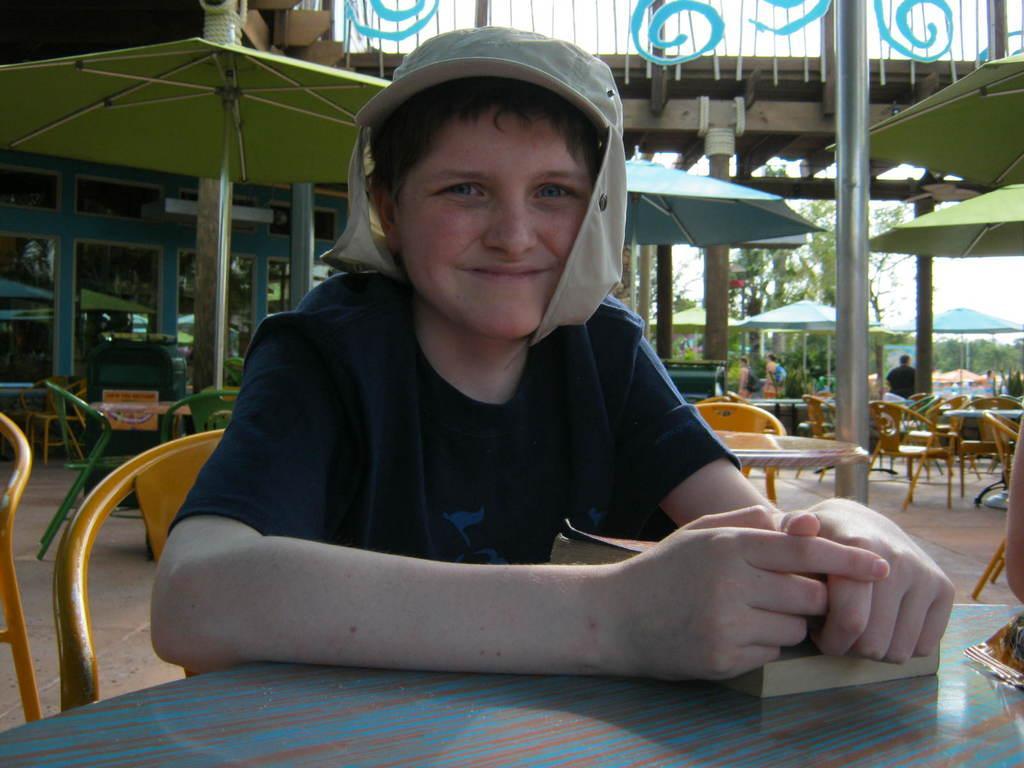Could you give a brief overview of what you see in this image? In this picture we can see a person holding a book and sitting on the chair. We can see a packet on the table. There are many chairs and tables. We can see many umbrellas and few people at the back. There is a building and a glass. Few trees are visible in the background. 